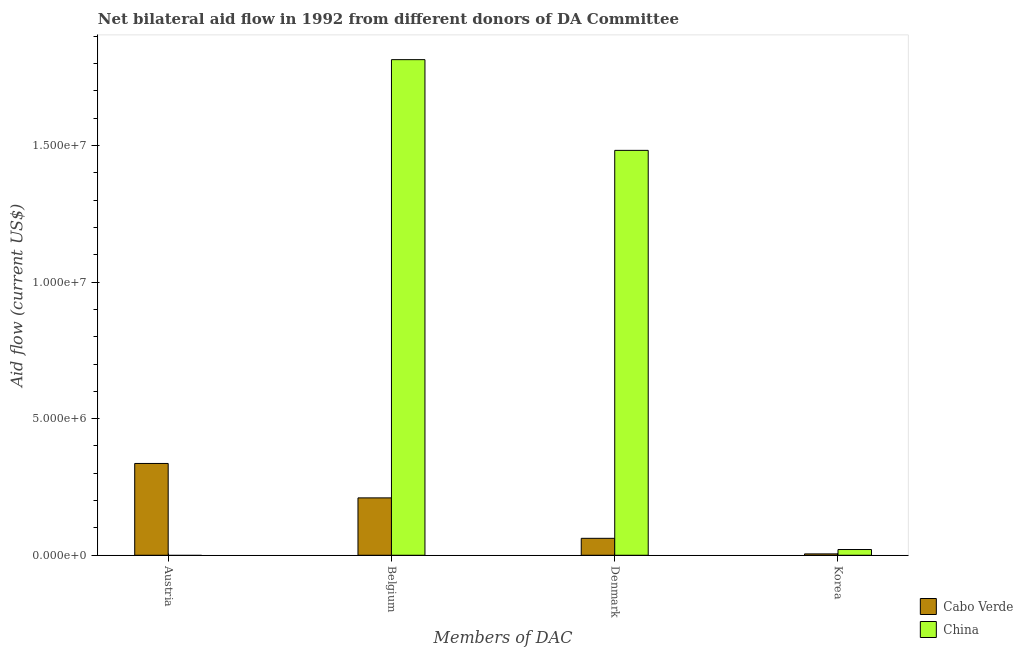How many bars are there on the 4th tick from the left?
Make the answer very short. 2. What is the label of the 4th group of bars from the left?
Offer a very short reply. Korea. What is the amount of aid given by denmark in Cabo Verde?
Keep it short and to the point. 6.20e+05. Across all countries, what is the maximum amount of aid given by belgium?
Keep it short and to the point. 1.81e+07. Across all countries, what is the minimum amount of aid given by korea?
Provide a short and direct response. 5.00e+04. In which country was the amount of aid given by austria maximum?
Offer a terse response. Cabo Verde. What is the total amount of aid given by denmark in the graph?
Keep it short and to the point. 1.54e+07. What is the difference between the amount of aid given by belgium in Cabo Verde and that in China?
Offer a very short reply. -1.60e+07. What is the difference between the amount of aid given by austria in China and the amount of aid given by denmark in Cabo Verde?
Provide a succinct answer. -6.20e+05. What is the average amount of aid given by denmark per country?
Offer a terse response. 7.72e+06. What is the difference between the amount of aid given by belgium and amount of aid given by austria in Cabo Verde?
Offer a very short reply. -1.26e+06. What is the ratio of the amount of aid given by denmark in China to that in Cabo Verde?
Make the answer very short. 23.9. Is the amount of aid given by korea in Cabo Verde less than that in China?
Your answer should be compact. Yes. What is the difference between the highest and the second highest amount of aid given by korea?
Offer a terse response. 1.60e+05. What is the difference between the highest and the lowest amount of aid given by denmark?
Offer a terse response. 1.42e+07. What is the difference between two consecutive major ticks on the Y-axis?
Make the answer very short. 5.00e+06. Does the graph contain grids?
Ensure brevity in your answer.  No. Where does the legend appear in the graph?
Provide a short and direct response. Bottom right. What is the title of the graph?
Your answer should be compact. Net bilateral aid flow in 1992 from different donors of DA Committee. Does "Cote d'Ivoire" appear as one of the legend labels in the graph?
Ensure brevity in your answer.  No. What is the label or title of the X-axis?
Your answer should be compact. Members of DAC. What is the label or title of the Y-axis?
Make the answer very short. Aid flow (current US$). What is the Aid flow (current US$) of Cabo Verde in Austria?
Ensure brevity in your answer.  3.36e+06. What is the Aid flow (current US$) of Cabo Verde in Belgium?
Your answer should be compact. 2.10e+06. What is the Aid flow (current US$) of China in Belgium?
Keep it short and to the point. 1.81e+07. What is the Aid flow (current US$) in Cabo Verde in Denmark?
Your answer should be compact. 6.20e+05. What is the Aid flow (current US$) of China in Denmark?
Make the answer very short. 1.48e+07. What is the Aid flow (current US$) in China in Korea?
Provide a short and direct response. 2.10e+05. Across all Members of DAC, what is the maximum Aid flow (current US$) of Cabo Verde?
Your answer should be very brief. 3.36e+06. Across all Members of DAC, what is the maximum Aid flow (current US$) of China?
Provide a short and direct response. 1.81e+07. Across all Members of DAC, what is the minimum Aid flow (current US$) of Cabo Verde?
Give a very brief answer. 5.00e+04. Across all Members of DAC, what is the minimum Aid flow (current US$) of China?
Your response must be concise. 0. What is the total Aid flow (current US$) in Cabo Verde in the graph?
Make the answer very short. 6.13e+06. What is the total Aid flow (current US$) in China in the graph?
Offer a very short reply. 3.32e+07. What is the difference between the Aid flow (current US$) of Cabo Verde in Austria and that in Belgium?
Keep it short and to the point. 1.26e+06. What is the difference between the Aid flow (current US$) of Cabo Verde in Austria and that in Denmark?
Provide a short and direct response. 2.74e+06. What is the difference between the Aid flow (current US$) of Cabo Verde in Austria and that in Korea?
Offer a terse response. 3.31e+06. What is the difference between the Aid flow (current US$) of Cabo Verde in Belgium and that in Denmark?
Provide a succinct answer. 1.48e+06. What is the difference between the Aid flow (current US$) in China in Belgium and that in Denmark?
Give a very brief answer. 3.32e+06. What is the difference between the Aid flow (current US$) in Cabo Verde in Belgium and that in Korea?
Provide a short and direct response. 2.05e+06. What is the difference between the Aid flow (current US$) in China in Belgium and that in Korea?
Keep it short and to the point. 1.79e+07. What is the difference between the Aid flow (current US$) in Cabo Verde in Denmark and that in Korea?
Your answer should be very brief. 5.70e+05. What is the difference between the Aid flow (current US$) in China in Denmark and that in Korea?
Offer a terse response. 1.46e+07. What is the difference between the Aid flow (current US$) of Cabo Verde in Austria and the Aid flow (current US$) of China in Belgium?
Make the answer very short. -1.48e+07. What is the difference between the Aid flow (current US$) in Cabo Verde in Austria and the Aid flow (current US$) in China in Denmark?
Provide a short and direct response. -1.15e+07. What is the difference between the Aid flow (current US$) in Cabo Verde in Austria and the Aid flow (current US$) in China in Korea?
Offer a terse response. 3.15e+06. What is the difference between the Aid flow (current US$) of Cabo Verde in Belgium and the Aid flow (current US$) of China in Denmark?
Provide a succinct answer. -1.27e+07. What is the difference between the Aid flow (current US$) of Cabo Verde in Belgium and the Aid flow (current US$) of China in Korea?
Your response must be concise. 1.89e+06. What is the difference between the Aid flow (current US$) of Cabo Verde in Denmark and the Aid flow (current US$) of China in Korea?
Provide a succinct answer. 4.10e+05. What is the average Aid flow (current US$) in Cabo Verde per Members of DAC?
Offer a terse response. 1.53e+06. What is the average Aid flow (current US$) in China per Members of DAC?
Your answer should be compact. 8.29e+06. What is the difference between the Aid flow (current US$) in Cabo Verde and Aid flow (current US$) in China in Belgium?
Offer a very short reply. -1.60e+07. What is the difference between the Aid flow (current US$) of Cabo Verde and Aid flow (current US$) of China in Denmark?
Provide a succinct answer. -1.42e+07. What is the ratio of the Aid flow (current US$) of Cabo Verde in Austria to that in Denmark?
Provide a short and direct response. 5.42. What is the ratio of the Aid flow (current US$) in Cabo Verde in Austria to that in Korea?
Offer a terse response. 67.2. What is the ratio of the Aid flow (current US$) of Cabo Verde in Belgium to that in Denmark?
Ensure brevity in your answer.  3.39. What is the ratio of the Aid flow (current US$) of China in Belgium to that in Denmark?
Your response must be concise. 1.22. What is the ratio of the Aid flow (current US$) in Cabo Verde in Belgium to that in Korea?
Give a very brief answer. 42. What is the ratio of the Aid flow (current US$) of China in Belgium to that in Korea?
Provide a short and direct response. 86.38. What is the ratio of the Aid flow (current US$) in China in Denmark to that in Korea?
Your answer should be compact. 70.57. What is the difference between the highest and the second highest Aid flow (current US$) of Cabo Verde?
Make the answer very short. 1.26e+06. What is the difference between the highest and the second highest Aid flow (current US$) in China?
Offer a terse response. 3.32e+06. What is the difference between the highest and the lowest Aid flow (current US$) of Cabo Verde?
Give a very brief answer. 3.31e+06. What is the difference between the highest and the lowest Aid flow (current US$) of China?
Offer a very short reply. 1.81e+07. 